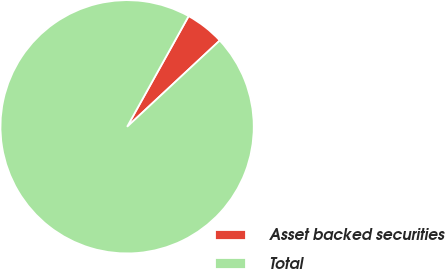Convert chart. <chart><loc_0><loc_0><loc_500><loc_500><pie_chart><fcel>Asset backed securities<fcel>Total<nl><fcel>4.99%<fcel>95.01%<nl></chart> 